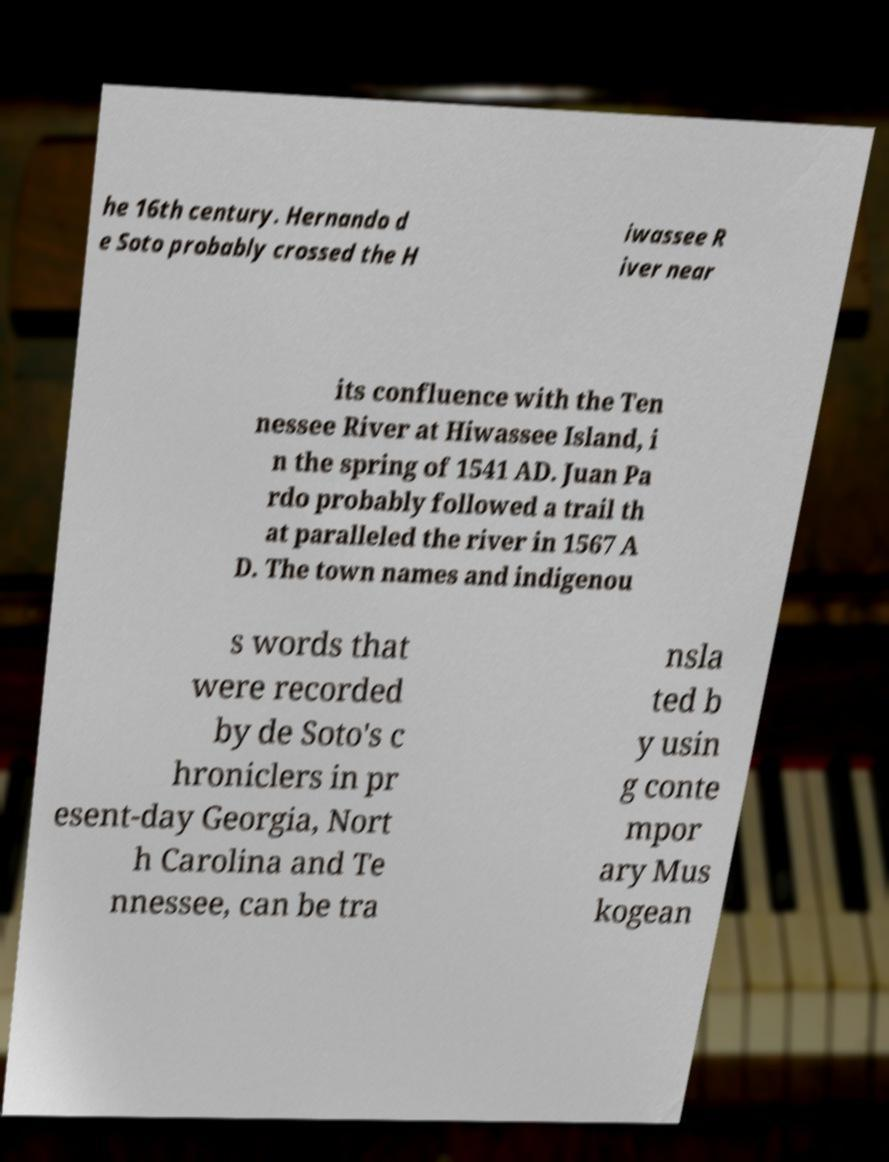Could you extract and type out the text from this image? he 16th century. Hernando d e Soto probably crossed the H iwassee R iver near its confluence with the Ten nessee River at Hiwassee Island, i n the spring of 1541 AD. Juan Pa rdo probably followed a trail th at paralleled the river in 1567 A D. The town names and indigenou s words that were recorded by de Soto's c hroniclers in pr esent-day Georgia, Nort h Carolina and Te nnessee, can be tra nsla ted b y usin g conte mpor ary Mus kogean 